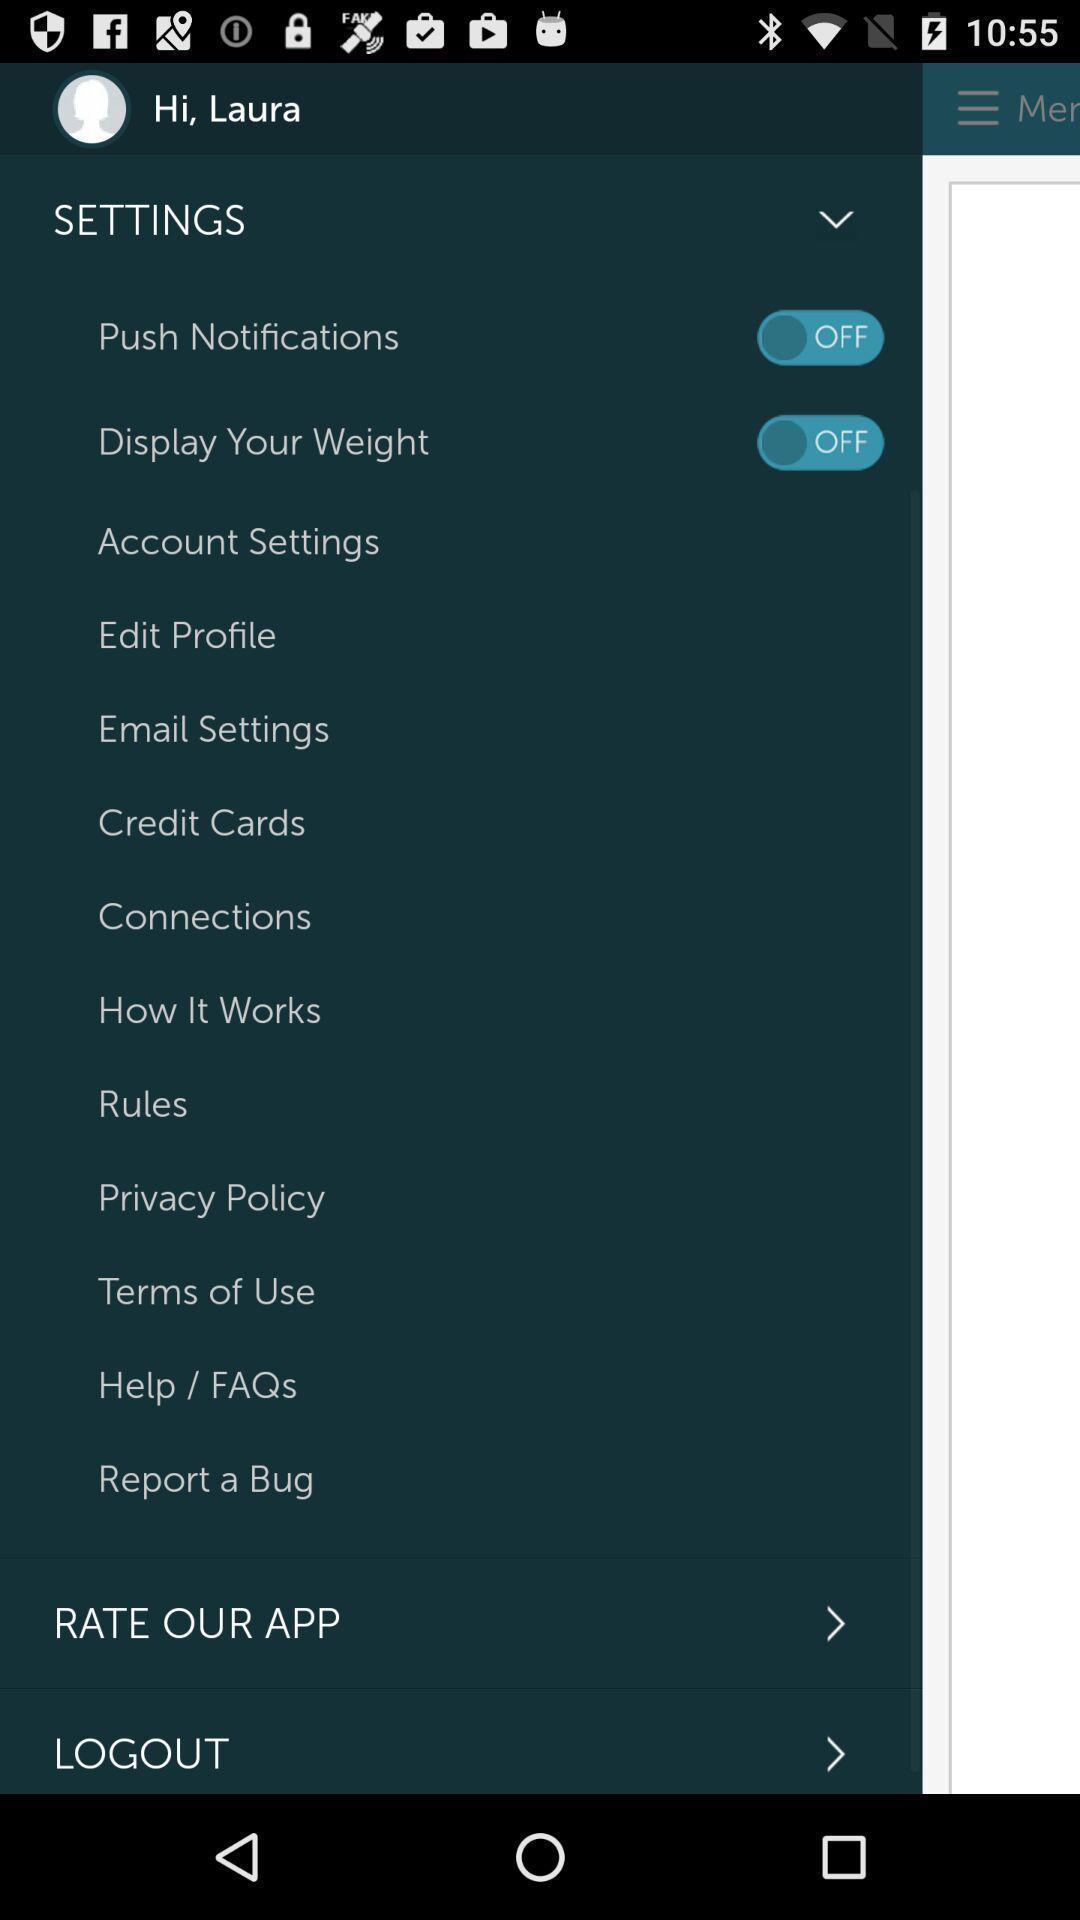Summarize the information in this screenshot. Screen displaying multiple setting options in user profile page. 